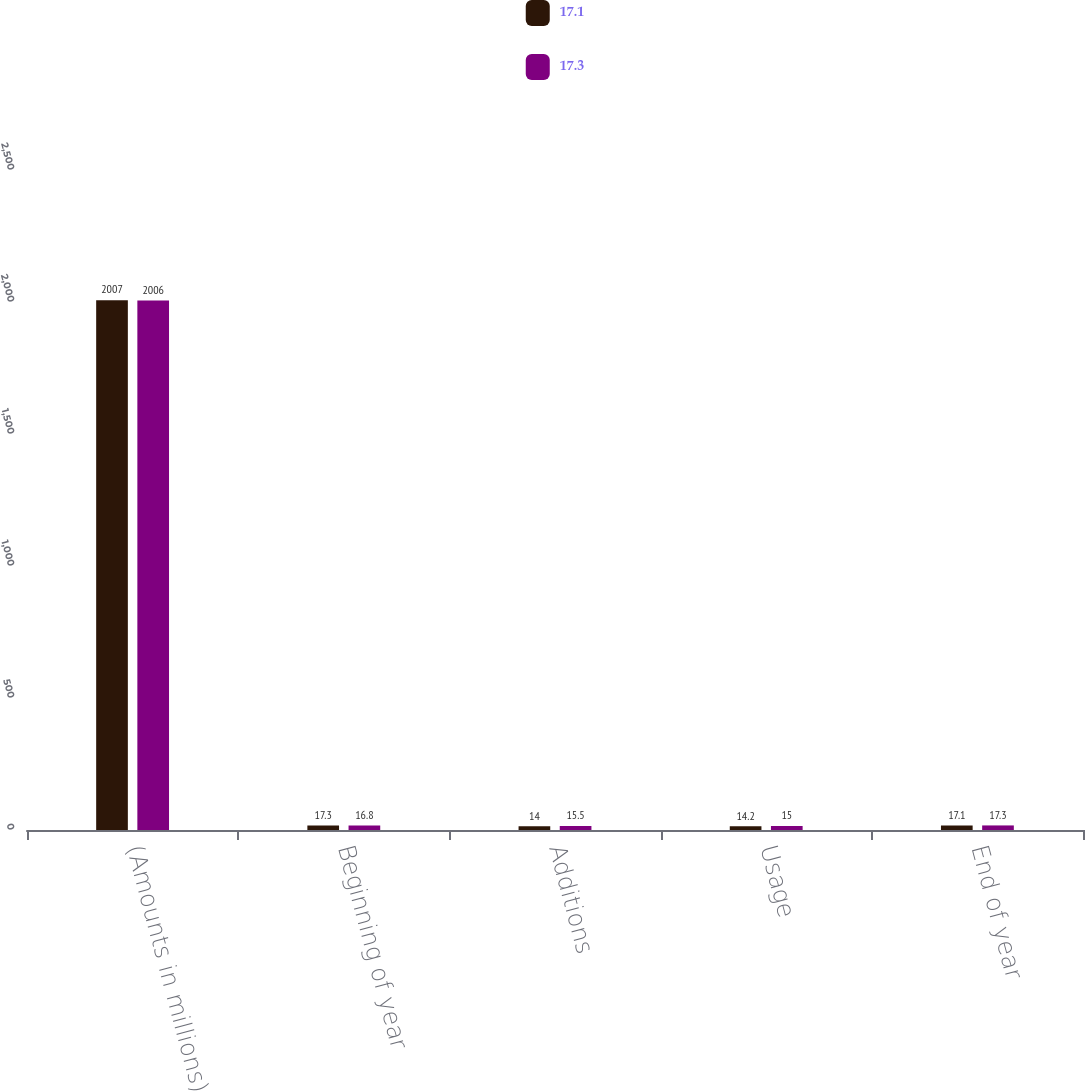Convert chart. <chart><loc_0><loc_0><loc_500><loc_500><stacked_bar_chart><ecel><fcel>(Amounts in millions)<fcel>Beginning of year<fcel>Additions<fcel>Usage<fcel>End of year<nl><fcel>17.1<fcel>2007<fcel>17.3<fcel>14<fcel>14.2<fcel>17.1<nl><fcel>17.3<fcel>2006<fcel>16.8<fcel>15.5<fcel>15<fcel>17.3<nl></chart> 